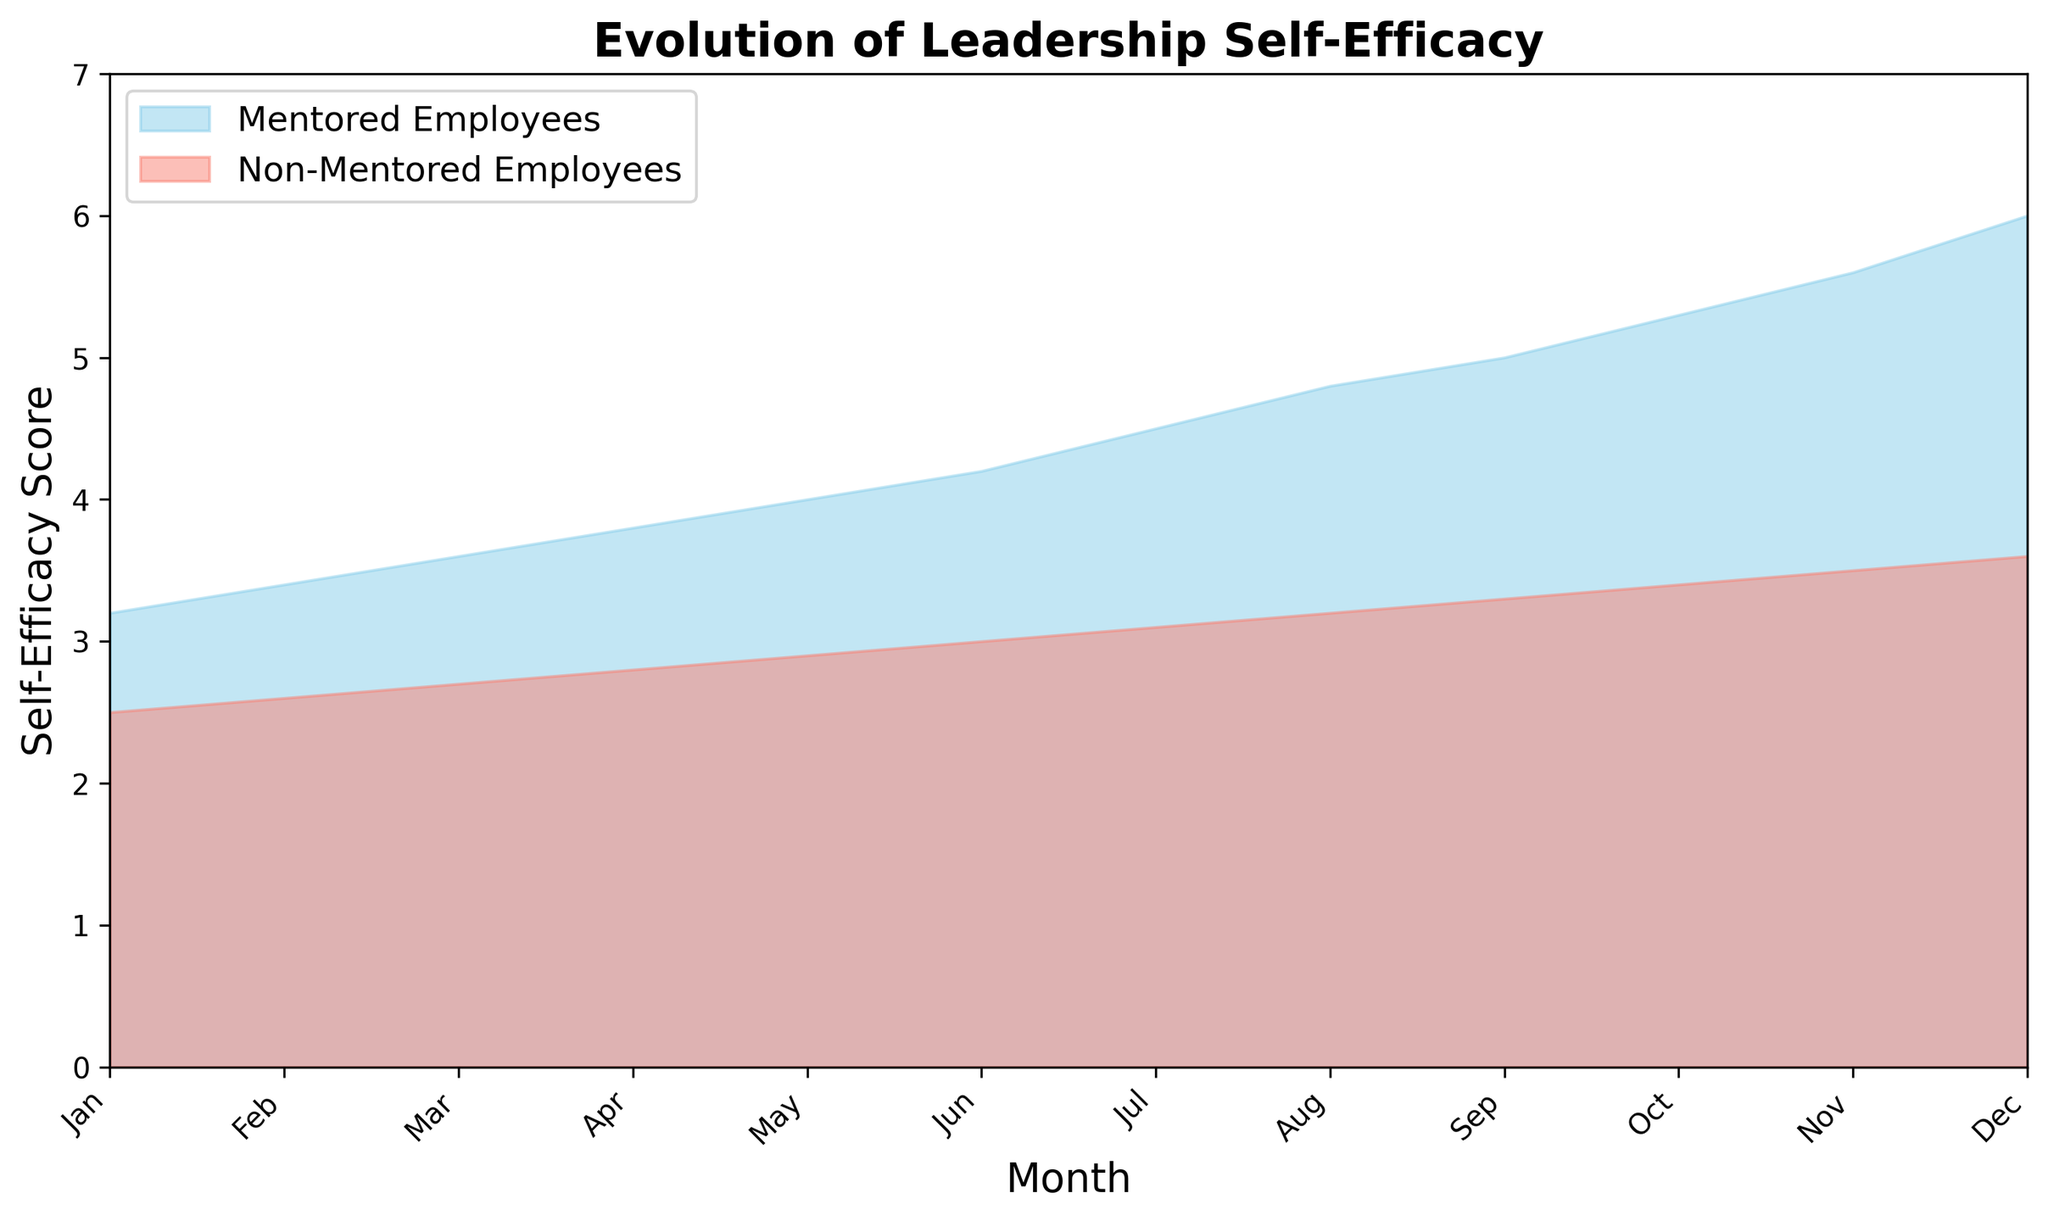What is the trend in self-efficacy scores over 12 months for mentored employees? The trend in self-efficacy scores for mentored employees is upward. Starting at 3.2 in January, the score increases each month, reaching 6.0 by December.
Answer: Upward How do the self-efficacy scores for mentored employees in January compare to those in December? In January, the self-efficacy score for mentored employees is 3.2, while in December, it is 6.0. The score has increased.
Answer: Increased Which group has consistently higher self-efficacy scores throughout the year, mentored or non-mentored employees? Throughout the year, mentored employees consistently have higher self-efficacy scores compared to non-mentored employees.
Answer: Mentored employees By how much did the self-efficacy score for mentored employees increase from January to June? In January, the self-efficacy score for mentored employees is 3.2, and in June, it is 4.2. The increase is 4.2 - 3.2.
Answer: 1.0 What is the difference in self-efficacy scores between mentored and non-mentored employees in July? In July, the self-efficacy score for mentored employees is 4.5, while for non-mentored employees, it is 3.1. The difference is 4.5 - 3.1.
Answer: 1.4 What is the average self-efficacy score for mentored employees over the 12 months? Sum of the scores for mentored employees over 12 months is (3.2 + 3.4 + 3.6 + 3.8 + 4.0 + 4.2 + 4.5 + 4.8 + 5.0 + 5.3 + 5.6 + 6.0) = 53.4, divide by 12 months.
Answer: 4.45 In which month do non-mentored employees reach a self-efficacy score of 3.5? The self-efficacy score for non-mentored employees reaches 3.5 in November.
Answer: November Which month shows the greatest increase in self-efficacy score for mentored employees compared to the previous month? To find the month with the greatest increase, we calculate the differences: Feb-Jan (0.2), Mar-Feb (0.2), Apr-Mar (0.2), May-Apr (0.2), Jun-May (0.2), Jul-Jun (0.3), Aug-Jul (0.3), Sep-Aug (0.2), Oct-Sep (0.3), Nov-Oct (0.3), Dec-Nov (0.4). The greatest increase is in December.
Answer: December How does the self-efficacy score of non-mentored employees in June compare to that of mentored employees in February? The self-efficacy score for non-mentored employees in June is 3.0, whereas for mentored employees in February, it is 3.4. The score for non-mentored employees in June is lower.
Answer: Lower What is the total increase in self-efficacy scores for non-mentored employees between July and December? The self-efficacy score for non-mentored employees in July is 3.1 and in December is 3.6. The total increase is 3.6 - 3.1.
Answer: 0.5 